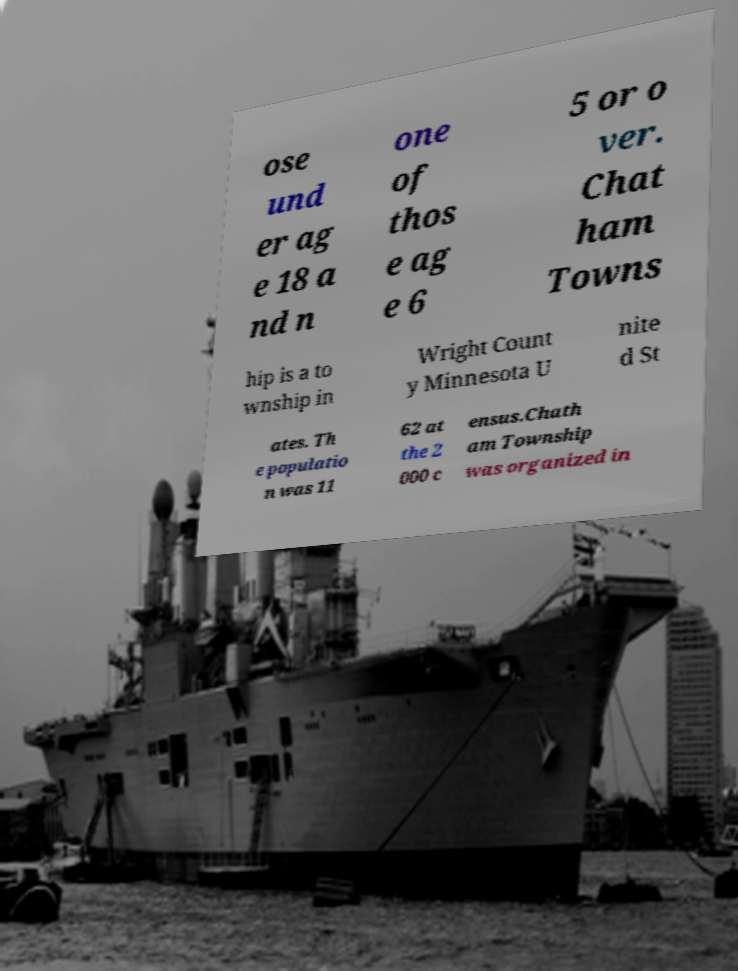Could you extract and type out the text from this image? ose und er ag e 18 a nd n one of thos e ag e 6 5 or o ver. Chat ham Towns hip is a to wnship in Wright Count y Minnesota U nite d St ates. Th e populatio n was 11 62 at the 2 000 c ensus.Chath am Township was organized in 